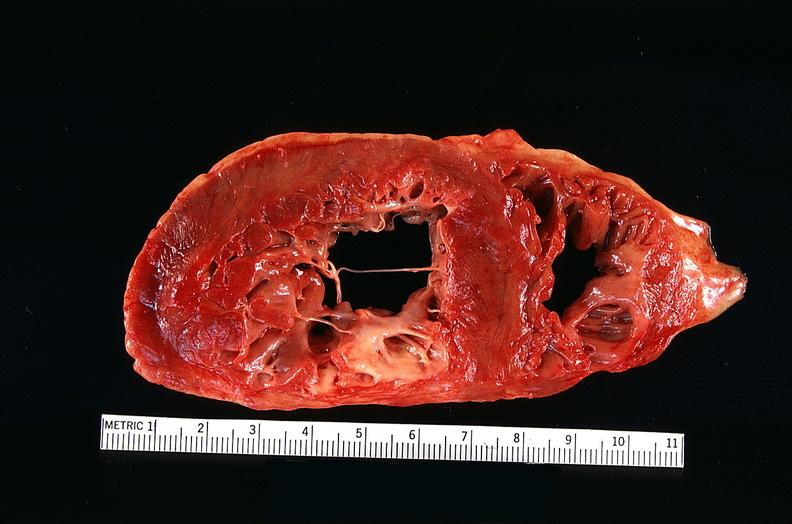what is present?
Answer the question using a single word or phrase. Cardiovascular 